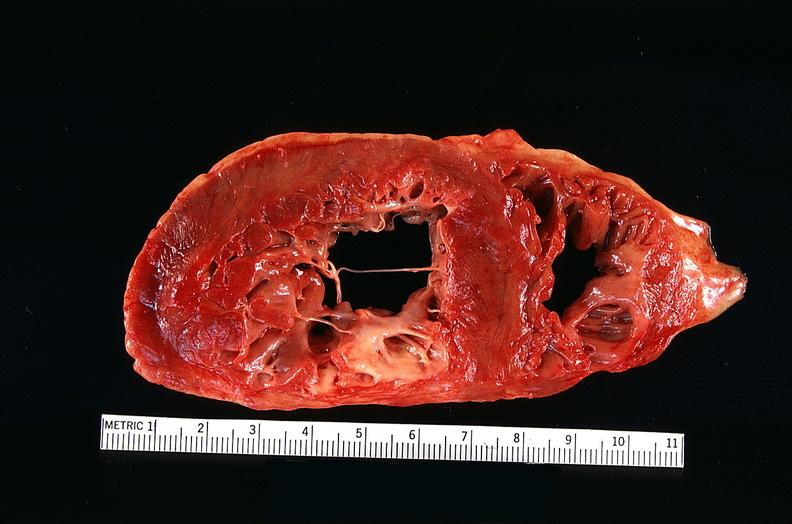what is present?
Answer the question using a single word or phrase. Cardiovascular 